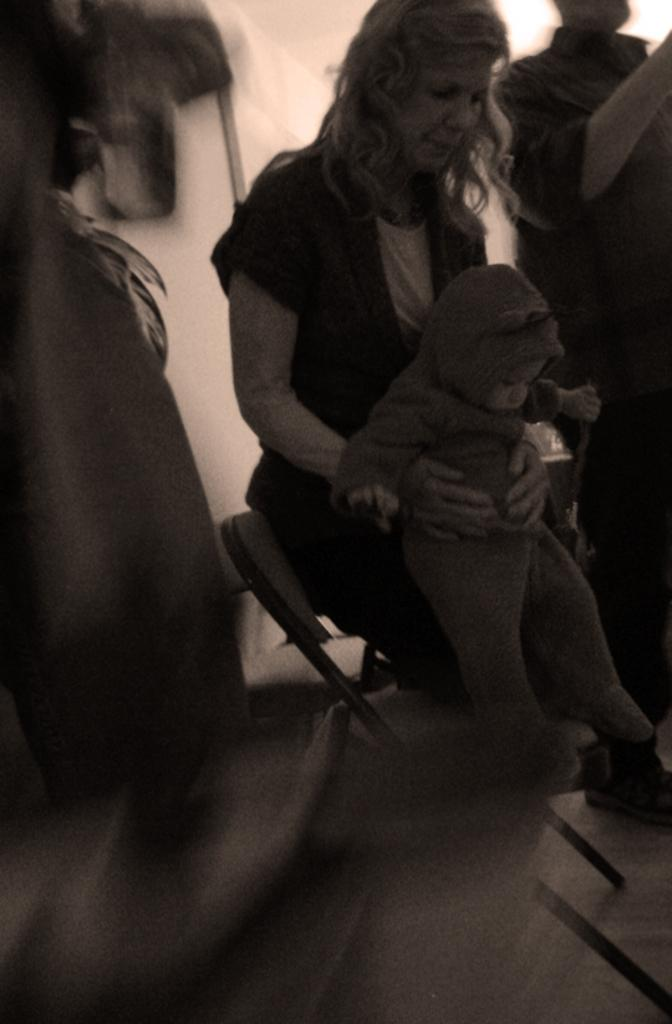What is happening in the image? There are people standing in the image, and a woman is holding a baby in her hand. Can you describe the woman's action in the image? The woman is holding a baby in her hand. What is located on the left side of the image? There is a chair on the left side of the image, but it is blurred. What type of muscle is being flexed by the baby in the image? There is no indication in the image that the baby is flexing any muscles. What color is the curtain behind the people in the image? There is no curtain visible in the image. 